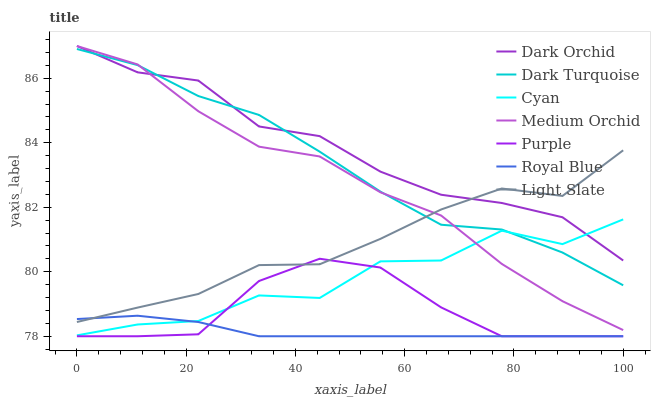Does Royal Blue have the minimum area under the curve?
Answer yes or no. Yes. Does Dark Orchid have the maximum area under the curve?
Answer yes or no. Yes. Does Purple have the minimum area under the curve?
Answer yes or no. No. Does Purple have the maximum area under the curve?
Answer yes or no. No. Is Royal Blue the smoothest?
Answer yes or no. Yes. Is Cyan the roughest?
Answer yes or no. Yes. Is Purple the smoothest?
Answer yes or no. No. Is Purple the roughest?
Answer yes or no. No. Does Purple have the lowest value?
Answer yes or no. Yes. Does Dark Turquoise have the lowest value?
Answer yes or no. No. Does Dark Orchid have the highest value?
Answer yes or no. Yes. Does Purple have the highest value?
Answer yes or no. No. Is Royal Blue less than Medium Orchid?
Answer yes or no. Yes. Is Dark Orchid greater than Purple?
Answer yes or no. Yes. Does Cyan intersect Medium Orchid?
Answer yes or no. Yes. Is Cyan less than Medium Orchid?
Answer yes or no. No. Is Cyan greater than Medium Orchid?
Answer yes or no. No. Does Royal Blue intersect Medium Orchid?
Answer yes or no. No. 